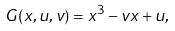<formula> <loc_0><loc_0><loc_500><loc_500>G ( x , u , v ) = x ^ { 3 } - v x + u ,</formula> 